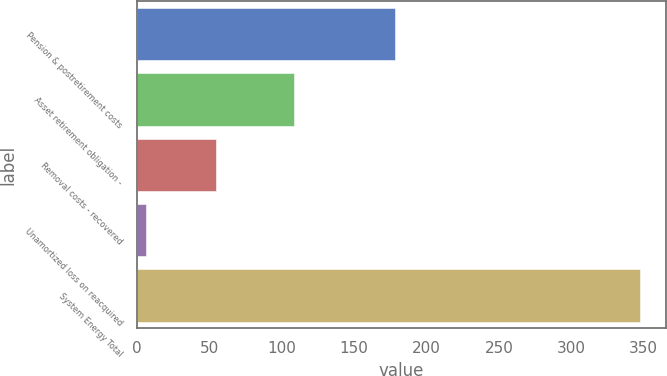<chart> <loc_0><loc_0><loc_500><loc_500><bar_chart><fcel>Pension & postretirement costs<fcel>Asset retirement obligation -<fcel>Removal costs - recovered<fcel>Unamortized loss on reacquired<fcel>System Energy Total<nl><fcel>178<fcel>108.6<fcel>54.8<fcel>6.4<fcel>347.8<nl></chart> 